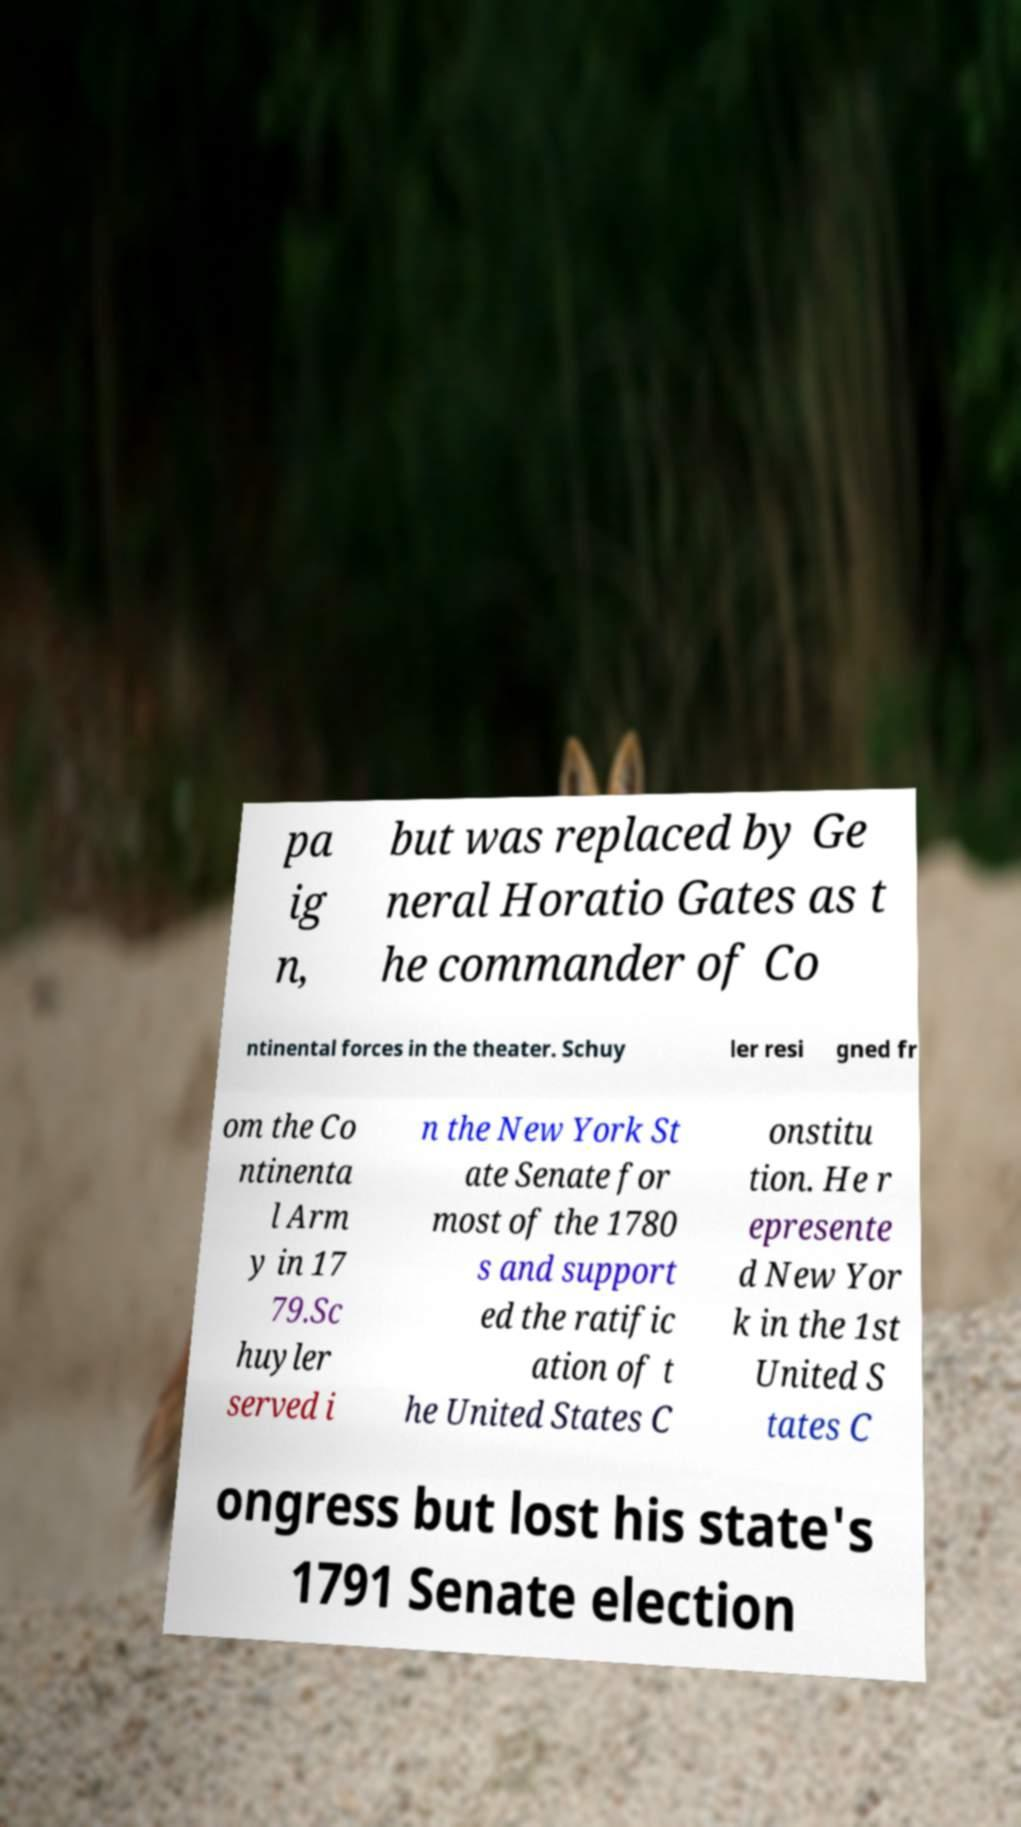I need the written content from this picture converted into text. Can you do that? pa ig n, but was replaced by Ge neral Horatio Gates as t he commander of Co ntinental forces in the theater. Schuy ler resi gned fr om the Co ntinenta l Arm y in 17 79.Sc huyler served i n the New York St ate Senate for most of the 1780 s and support ed the ratific ation of t he United States C onstitu tion. He r epresente d New Yor k in the 1st United S tates C ongress but lost his state's 1791 Senate election 